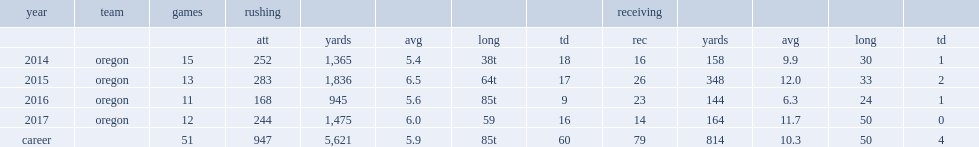How many rushing yards did freeman get in 2016? 945.0. 